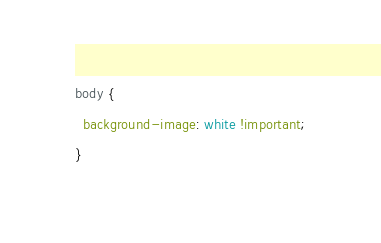Convert code to text. <code><loc_0><loc_0><loc_500><loc_500><_CSS_>body {
  background-image: white !important;
}
</code> 